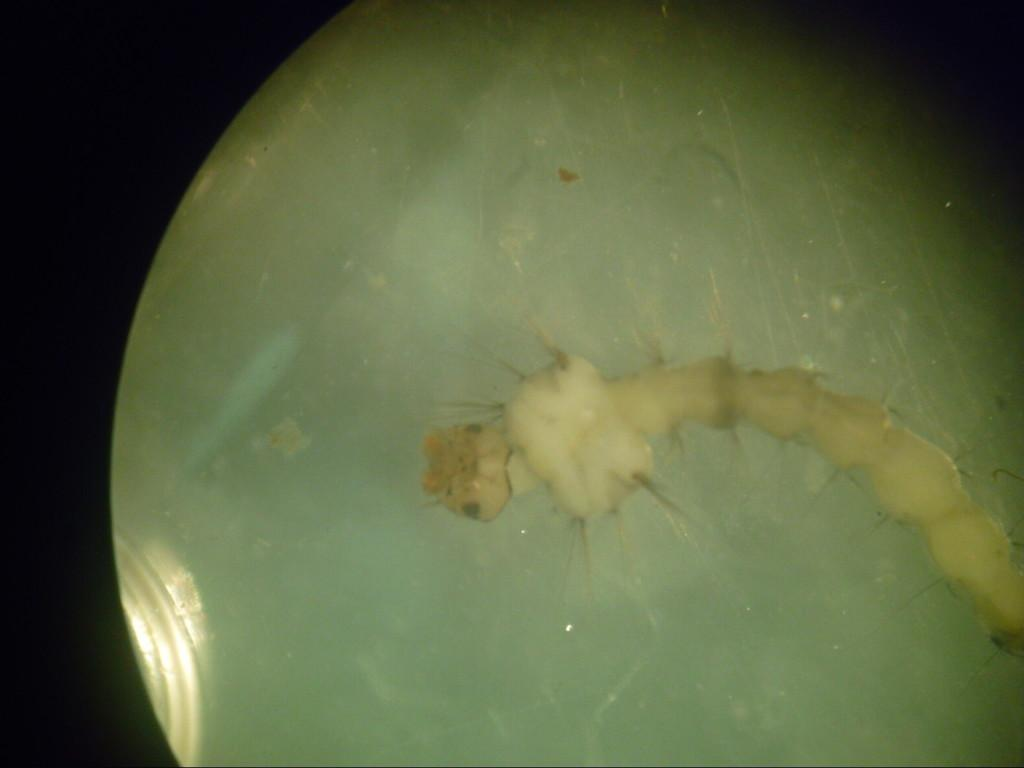What is the main subject of the image? The main subject of the image is a caterpillar. Where is the caterpillar located in the image? The caterpillar is in a glass in the image. What feature can be observed on the caterpillar? The caterpillar has spines. What is the purpose of the pocket in the image? There is no pocket present in the image. What type of instrument is being played in the image? There is no instrument present in the image. 